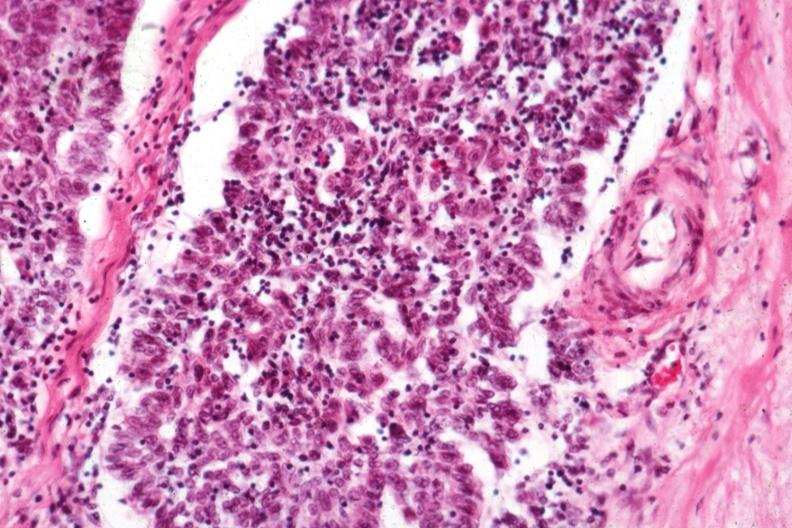what does this image show?
Answer the question using a single word or phrase. Predominant epithelial component 